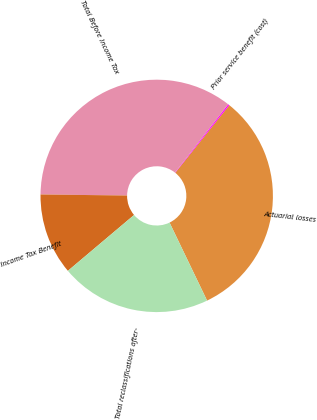Convert chart to OTSL. <chart><loc_0><loc_0><loc_500><loc_500><pie_chart><fcel>Actuarial losses<fcel>Prior service benefit (cost)<fcel>Total Before Income Tax<fcel>Income Tax Benefit<fcel>Total reclassifications after-<nl><fcel>32.13%<fcel>0.19%<fcel>35.35%<fcel>11.35%<fcel>20.98%<nl></chart> 